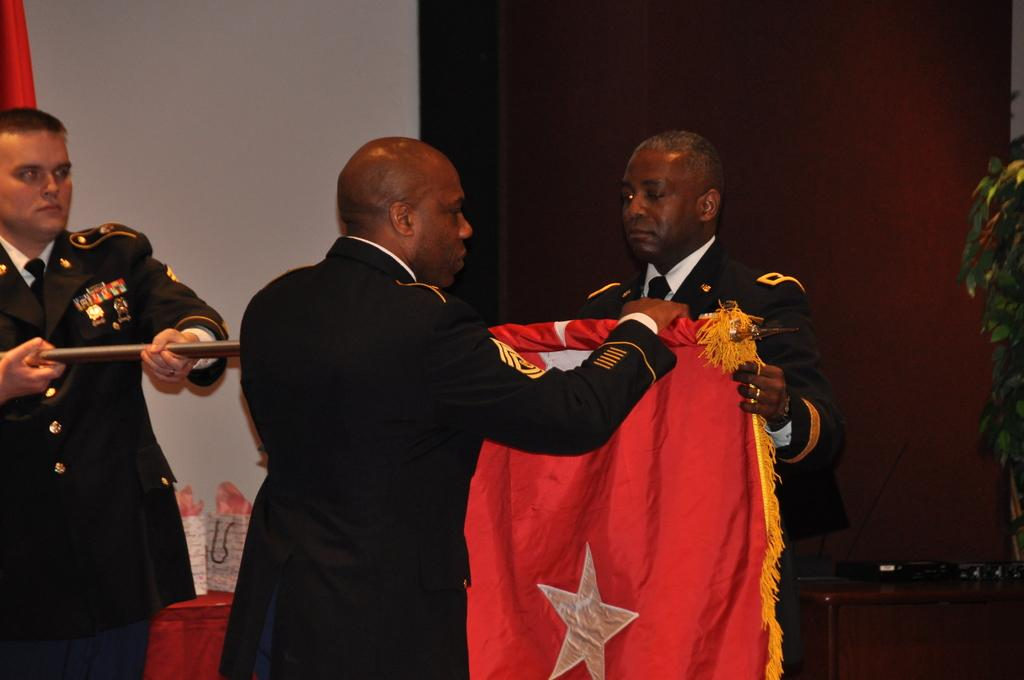How many people are in the image? There are people in the image, but the exact number is not specified. What are the people doing in the image? The people are standing in the image. What object are the people holding in the image? The people are holding a flag in the image. What type of fowl can be seen flying over the people in the image? There is no fowl visible in the image; it only shows people standing and holding a flag. 